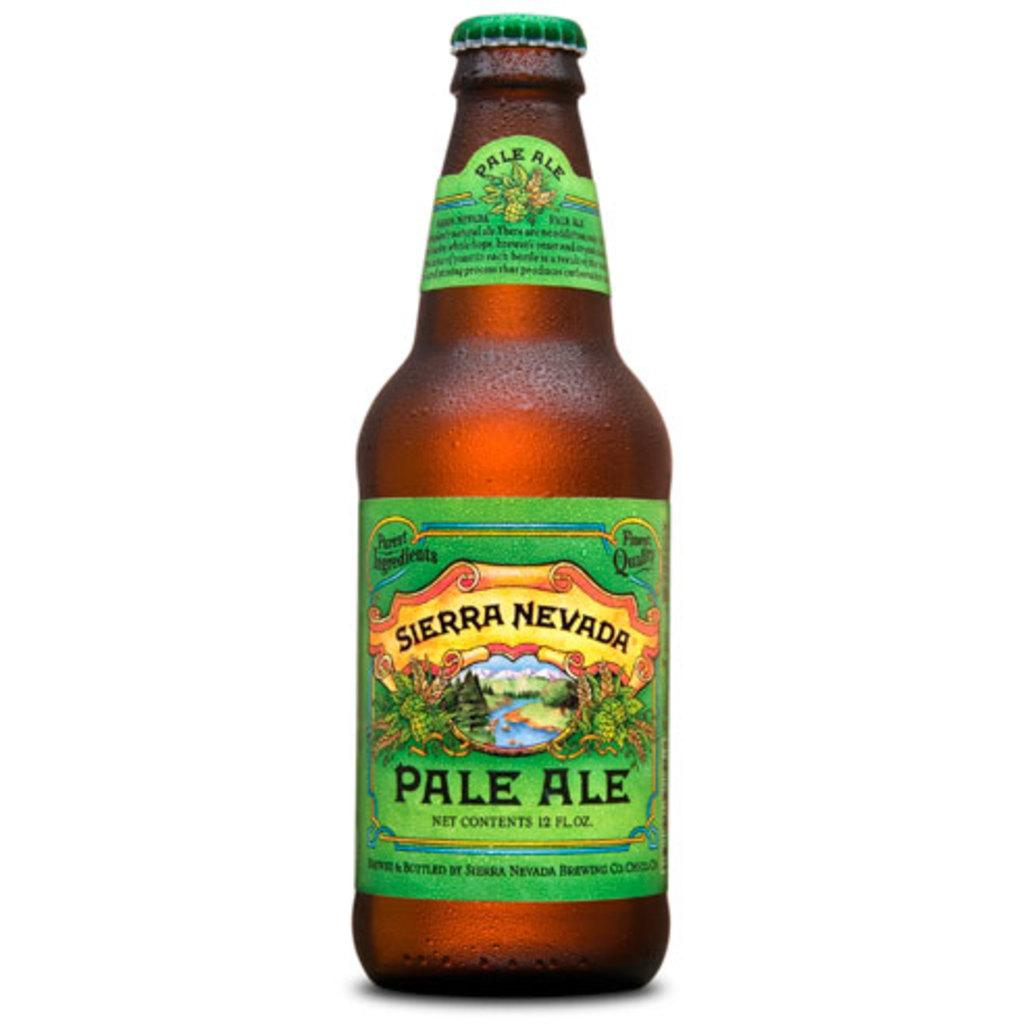<image>
Create a compact narrative representing the image presented. Pale Ale is presented in a bottle that is manufactured by Sierra Nevada. 